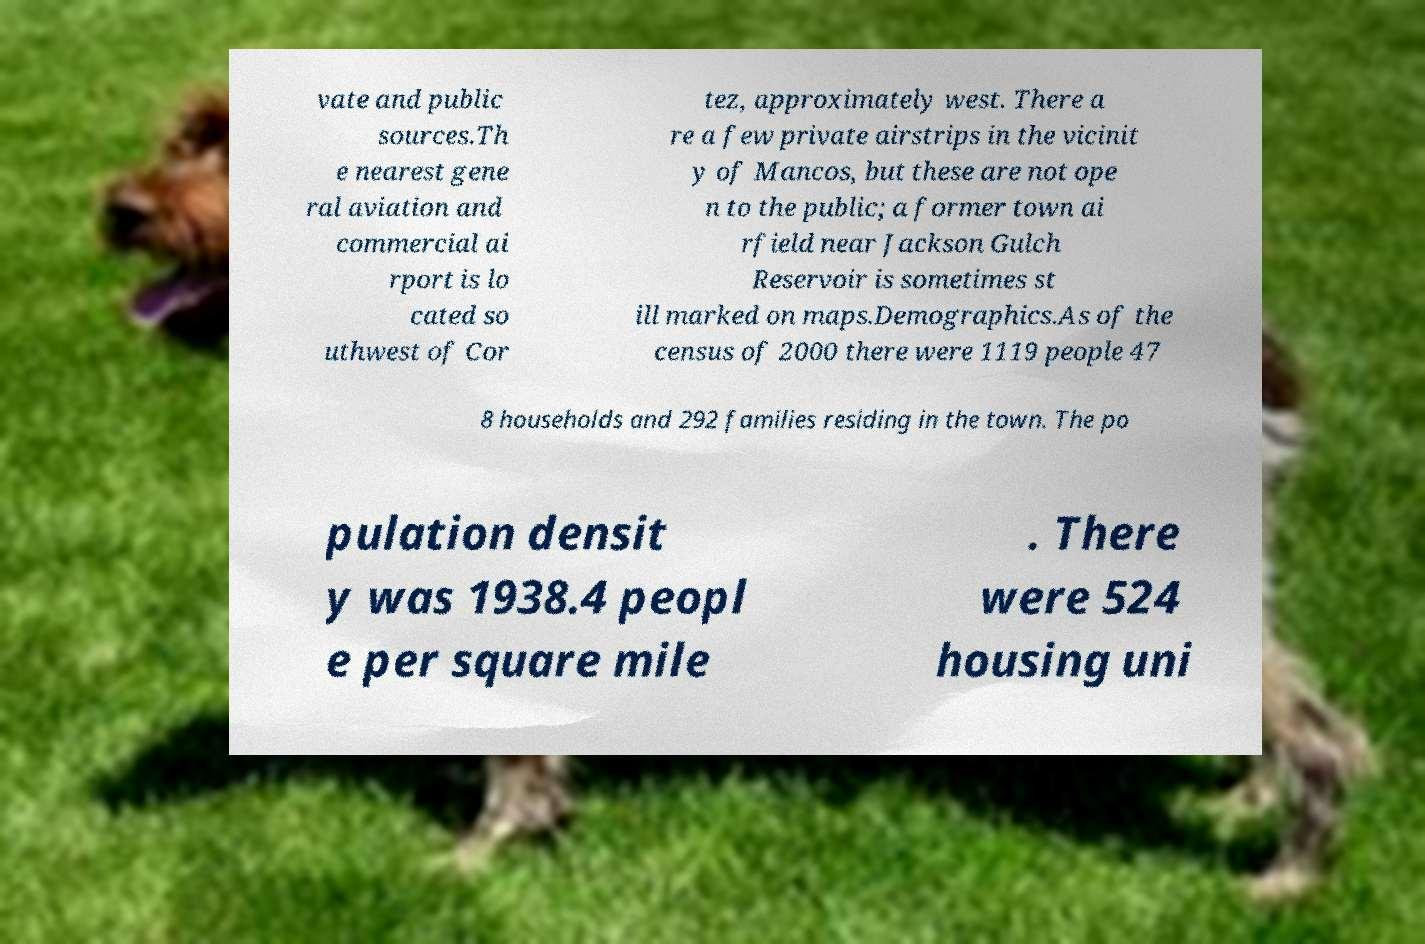I need the written content from this picture converted into text. Can you do that? vate and public sources.Th e nearest gene ral aviation and commercial ai rport is lo cated so uthwest of Cor tez, approximately west. There a re a few private airstrips in the vicinit y of Mancos, but these are not ope n to the public; a former town ai rfield near Jackson Gulch Reservoir is sometimes st ill marked on maps.Demographics.As of the census of 2000 there were 1119 people 47 8 households and 292 families residing in the town. The po pulation densit y was 1938.4 peopl e per square mile . There were 524 housing uni 